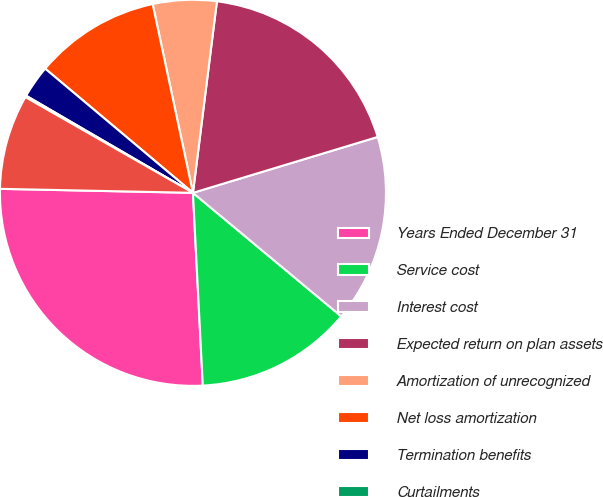Convert chart to OTSL. <chart><loc_0><loc_0><loc_500><loc_500><pie_chart><fcel>Years Ended December 31<fcel>Service cost<fcel>Interest cost<fcel>Expected return on plan assets<fcel>Amortization of unrecognized<fcel>Net loss amortization<fcel>Termination benefits<fcel>Curtailments<fcel>Net periodic benefit cost<nl><fcel>26.14%<fcel>13.13%<fcel>15.73%<fcel>18.34%<fcel>5.33%<fcel>10.53%<fcel>2.73%<fcel>0.13%<fcel>7.93%<nl></chart> 